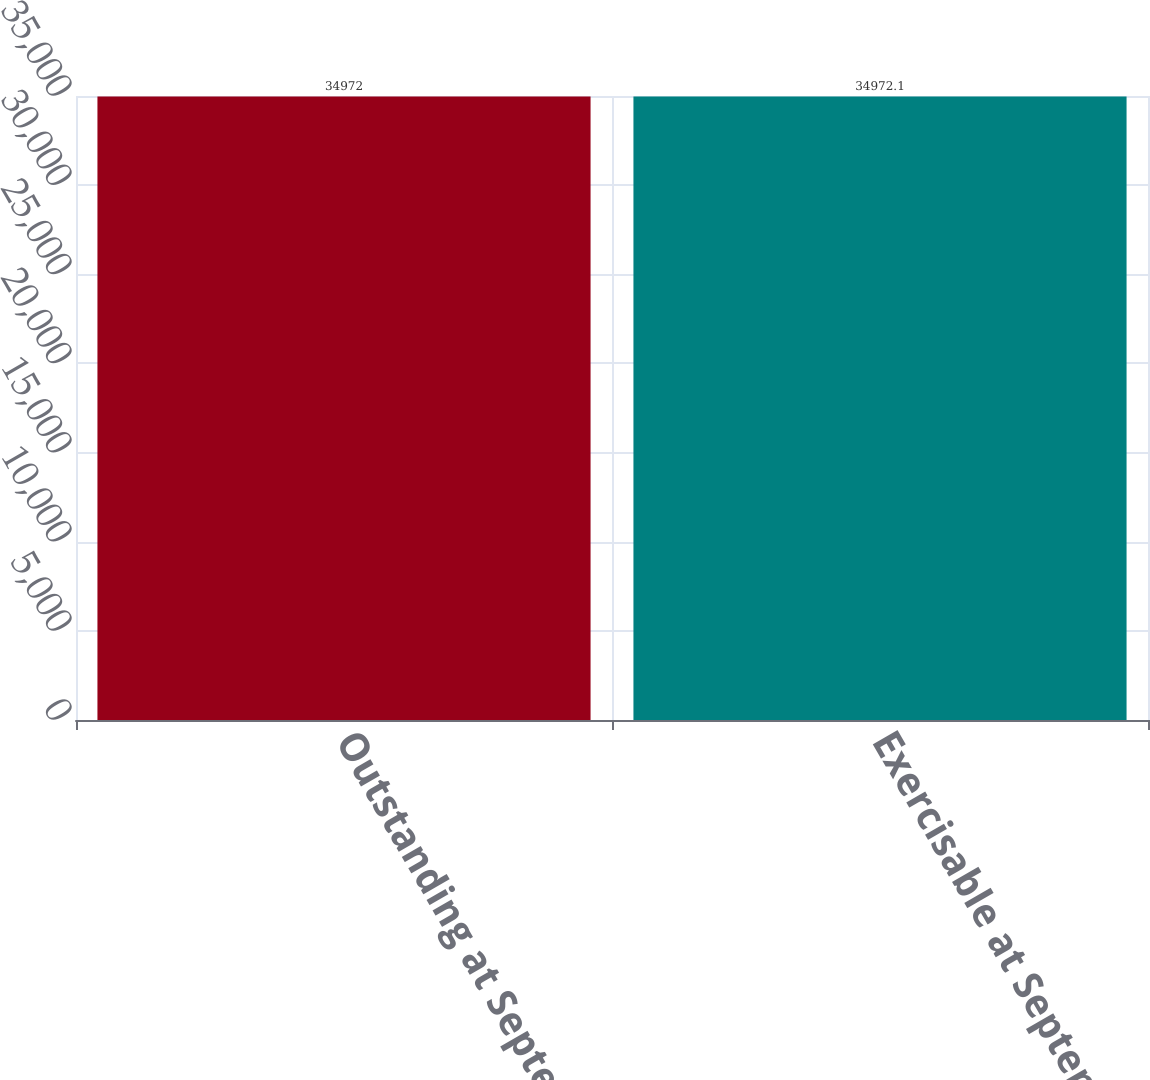<chart> <loc_0><loc_0><loc_500><loc_500><bar_chart><fcel>Outstanding at September 30<fcel>Exercisable at September 30<nl><fcel>34972<fcel>34972.1<nl></chart> 